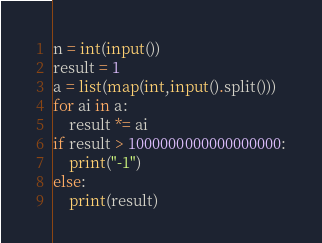<code> <loc_0><loc_0><loc_500><loc_500><_Python_>n = int(input())
result = 1
a = list(map(int,input().split()))
for ai in a:
    result *= ai
if result > 1000000000000000000:
    print("-1")
else:
    print(result)</code> 